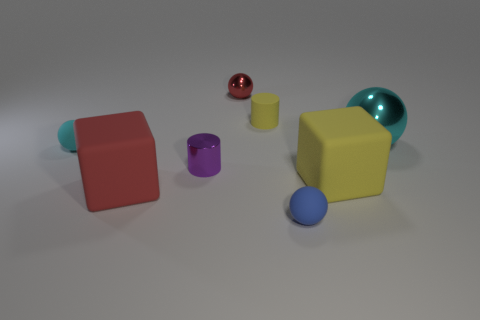There is a matte cylinder; is its color the same as the cylinder in front of the tiny cyan sphere?
Keep it short and to the point. No. What is the color of the rubber cube on the right side of the metal object that is in front of the tiny cyan sphere?
Give a very brief answer. Yellow. Are there any big shiny things that are to the left of the rubber sphere behind the rubber cube on the left side of the tiny yellow object?
Ensure brevity in your answer.  No. The cylinder that is made of the same material as the tiny blue ball is what color?
Provide a succinct answer. Yellow. What number of other small blue objects are the same material as the blue object?
Your answer should be compact. 0. Is the material of the blue ball the same as the small sphere that is behind the tiny cyan thing?
Provide a short and direct response. No. What number of objects are matte things that are in front of the yellow cube or matte things?
Keep it short and to the point. 5. What is the size of the rubber sphere in front of the tiny matte sphere behind the tiny matte ball that is on the right side of the purple cylinder?
Your answer should be very brief. Small. What material is the small sphere that is the same color as the large sphere?
Make the answer very short. Rubber. Are there any other things that have the same shape as the tiny purple object?
Your answer should be very brief. Yes. 